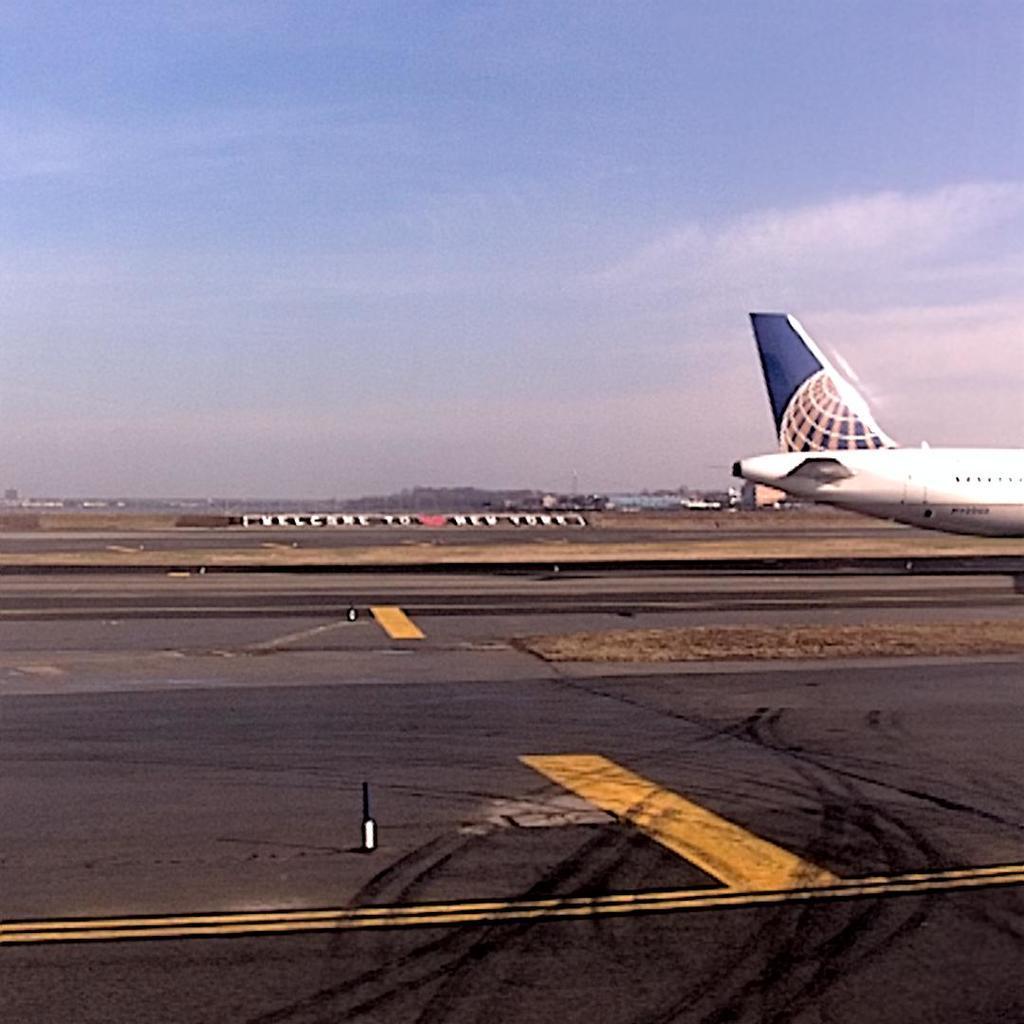How would you summarize this image in a sentence or two? In this image I can see an aircraft on the road. In the background I think there are some trees can be seen. I can also see the clouds and the sky in the back. 